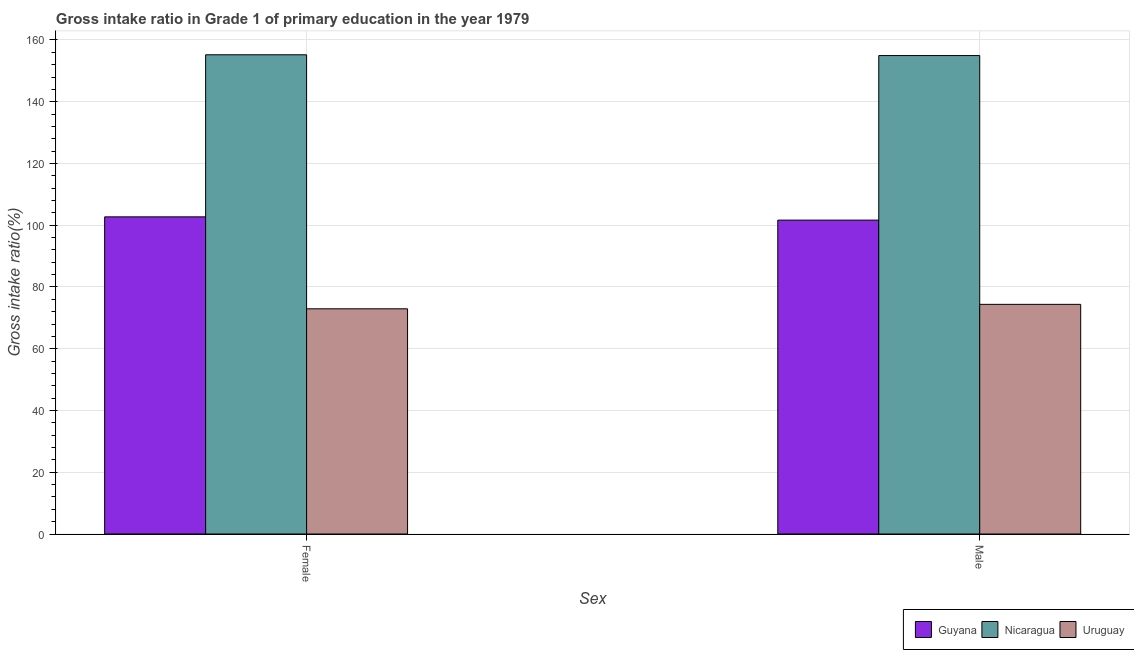How many different coloured bars are there?
Provide a succinct answer. 3. Are the number of bars per tick equal to the number of legend labels?
Offer a very short reply. Yes. How many bars are there on the 2nd tick from the left?
Offer a very short reply. 3. What is the label of the 1st group of bars from the left?
Provide a short and direct response. Female. What is the gross intake ratio(male) in Guyana?
Offer a very short reply. 101.66. Across all countries, what is the maximum gross intake ratio(male)?
Keep it short and to the point. 154.95. Across all countries, what is the minimum gross intake ratio(female)?
Give a very brief answer. 72.94. In which country was the gross intake ratio(female) maximum?
Your answer should be compact. Nicaragua. In which country was the gross intake ratio(female) minimum?
Your response must be concise. Uruguay. What is the total gross intake ratio(male) in the graph?
Ensure brevity in your answer.  330.99. What is the difference between the gross intake ratio(female) in Uruguay and that in Guyana?
Offer a terse response. -29.78. What is the difference between the gross intake ratio(female) in Nicaragua and the gross intake ratio(male) in Guyana?
Provide a short and direct response. 53.54. What is the average gross intake ratio(female) per country?
Make the answer very short. 110.28. What is the difference between the gross intake ratio(male) and gross intake ratio(female) in Nicaragua?
Your answer should be very brief. -0.25. In how many countries, is the gross intake ratio(female) greater than 36 %?
Provide a succinct answer. 3. What is the ratio of the gross intake ratio(male) in Guyana to that in Uruguay?
Your answer should be compact. 1.37. What does the 1st bar from the left in Female represents?
Offer a very short reply. Guyana. What does the 1st bar from the right in Male represents?
Provide a short and direct response. Uruguay. How many countries are there in the graph?
Provide a short and direct response. 3. Does the graph contain any zero values?
Offer a very short reply. No. Where does the legend appear in the graph?
Give a very brief answer. Bottom right. How many legend labels are there?
Keep it short and to the point. 3. How are the legend labels stacked?
Ensure brevity in your answer.  Horizontal. What is the title of the graph?
Make the answer very short. Gross intake ratio in Grade 1 of primary education in the year 1979. Does "Vietnam" appear as one of the legend labels in the graph?
Keep it short and to the point. No. What is the label or title of the X-axis?
Provide a succinct answer. Sex. What is the label or title of the Y-axis?
Offer a very short reply. Gross intake ratio(%). What is the Gross intake ratio(%) in Guyana in Female?
Provide a short and direct response. 102.71. What is the Gross intake ratio(%) in Nicaragua in Female?
Keep it short and to the point. 155.2. What is the Gross intake ratio(%) in Uruguay in Female?
Provide a short and direct response. 72.94. What is the Gross intake ratio(%) of Guyana in Male?
Your answer should be compact. 101.66. What is the Gross intake ratio(%) in Nicaragua in Male?
Your answer should be compact. 154.95. What is the Gross intake ratio(%) in Uruguay in Male?
Give a very brief answer. 74.38. Across all Sex, what is the maximum Gross intake ratio(%) in Guyana?
Offer a very short reply. 102.71. Across all Sex, what is the maximum Gross intake ratio(%) in Nicaragua?
Provide a short and direct response. 155.2. Across all Sex, what is the maximum Gross intake ratio(%) in Uruguay?
Provide a succinct answer. 74.38. Across all Sex, what is the minimum Gross intake ratio(%) of Guyana?
Make the answer very short. 101.66. Across all Sex, what is the minimum Gross intake ratio(%) in Nicaragua?
Your answer should be compact. 154.95. Across all Sex, what is the minimum Gross intake ratio(%) of Uruguay?
Make the answer very short. 72.94. What is the total Gross intake ratio(%) of Guyana in the graph?
Offer a very short reply. 204.37. What is the total Gross intake ratio(%) in Nicaragua in the graph?
Keep it short and to the point. 310.15. What is the total Gross intake ratio(%) of Uruguay in the graph?
Provide a succinct answer. 147.31. What is the difference between the Gross intake ratio(%) of Guyana in Female and that in Male?
Your response must be concise. 1.05. What is the difference between the Gross intake ratio(%) of Nicaragua in Female and that in Male?
Give a very brief answer. 0.25. What is the difference between the Gross intake ratio(%) of Uruguay in Female and that in Male?
Ensure brevity in your answer.  -1.44. What is the difference between the Gross intake ratio(%) in Guyana in Female and the Gross intake ratio(%) in Nicaragua in Male?
Keep it short and to the point. -52.24. What is the difference between the Gross intake ratio(%) of Guyana in Female and the Gross intake ratio(%) of Uruguay in Male?
Provide a short and direct response. 28.34. What is the difference between the Gross intake ratio(%) of Nicaragua in Female and the Gross intake ratio(%) of Uruguay in Male?
Your answer should be compact. 80.82. What is the average Gross intake ratio(%) of Guyana per Sex?
Your answer should be very brief. 102.19. What is the average Gross intake ratio(%) of Nicaragua per Sex?
Ensure brevity in your answer.  155.08. What is the average Gross intake ratio(%) of Uruguay per Sex?
Your response must be concise. 73.66. What is the difference between the Gross intake ratio(%) in Guyana and Gross intake ratio(%) in Nicaragua in Female?
Your answer should be compact. -52.49. What is the difference between the Gross intake ratio(%) of Guyana and Gross intake ratio(%) of Uruguay in Female?
Ensure brevity in your answer.  29.78. What is the difference between the Gross intake ratio(%) in Nicaragua and Gross intake ratio(%) in Uruguay in Female?
Your answer should be compact. 82.27. What is the difference between the Gross intake ratio(%) of Guyana and Gross intake ratio(%) of Nicaragua in Male?
Give a very brief answer. -53.29. What is the difference between the Gross intake ratio(%) of Guyana and Gross intake ratio(%) of Uruguay in Male?
Ensure brevity in your answer.  27.28. What is the difference between the Gross intake ratio(%) of Nicaragua and Gross intake ratio(%) of Uruguay in Male?
Offer a very short reply. 80.57. What is the ratio of the Gross intake ratio(%) in Guyana in Female to that in Male?
Offer a very short reply. 1.01. What is the ratio of the Gross intake ratio(%) of Nicaragua in Female to that in Male?
Offer a very short reply. 1. What is the ratio of the Gross intake ratio(%) of Uruguay in Female to that in Male?
Ensure brevity in your answer.  0.98. What is the difference between the highest and the second highest Gross intake ratio(%) in Guyana?
Your answer should be compact. 1.05. What is the difference between the highest and the second highest Gross intake ratio(%) in Nicaragua?
Provide a short and direct response. 0.25. What is the difference between the highest and the second highest Gross intake ratio(%) of Uruguay?
Ensure brevity in your answer.  1.44. What is the difference between the highest and the lowest Gross intake ratio(%) in Guyana?
Your answer should be very brief. 1.05. What is the difference between the highest and the lowest Gross intake ratio(%) of Nicaragua?
Make the answer very short. 0.25. What is the difference between the highest and the lowest Gross intake ratio(%) in Uruguay?
Offer a very short reply. 1.44. 